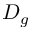<formula> <loc_0><loc_0><loc_500><loc_500>D _ { g }</formula> 